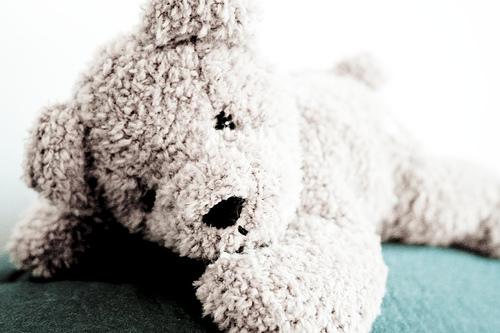Does the bear have button eyes?
Be succinct. No. Is this bear hugging something?
Answer briefly. No. Does this bear have a tail?
Keep it brief. Yes. 